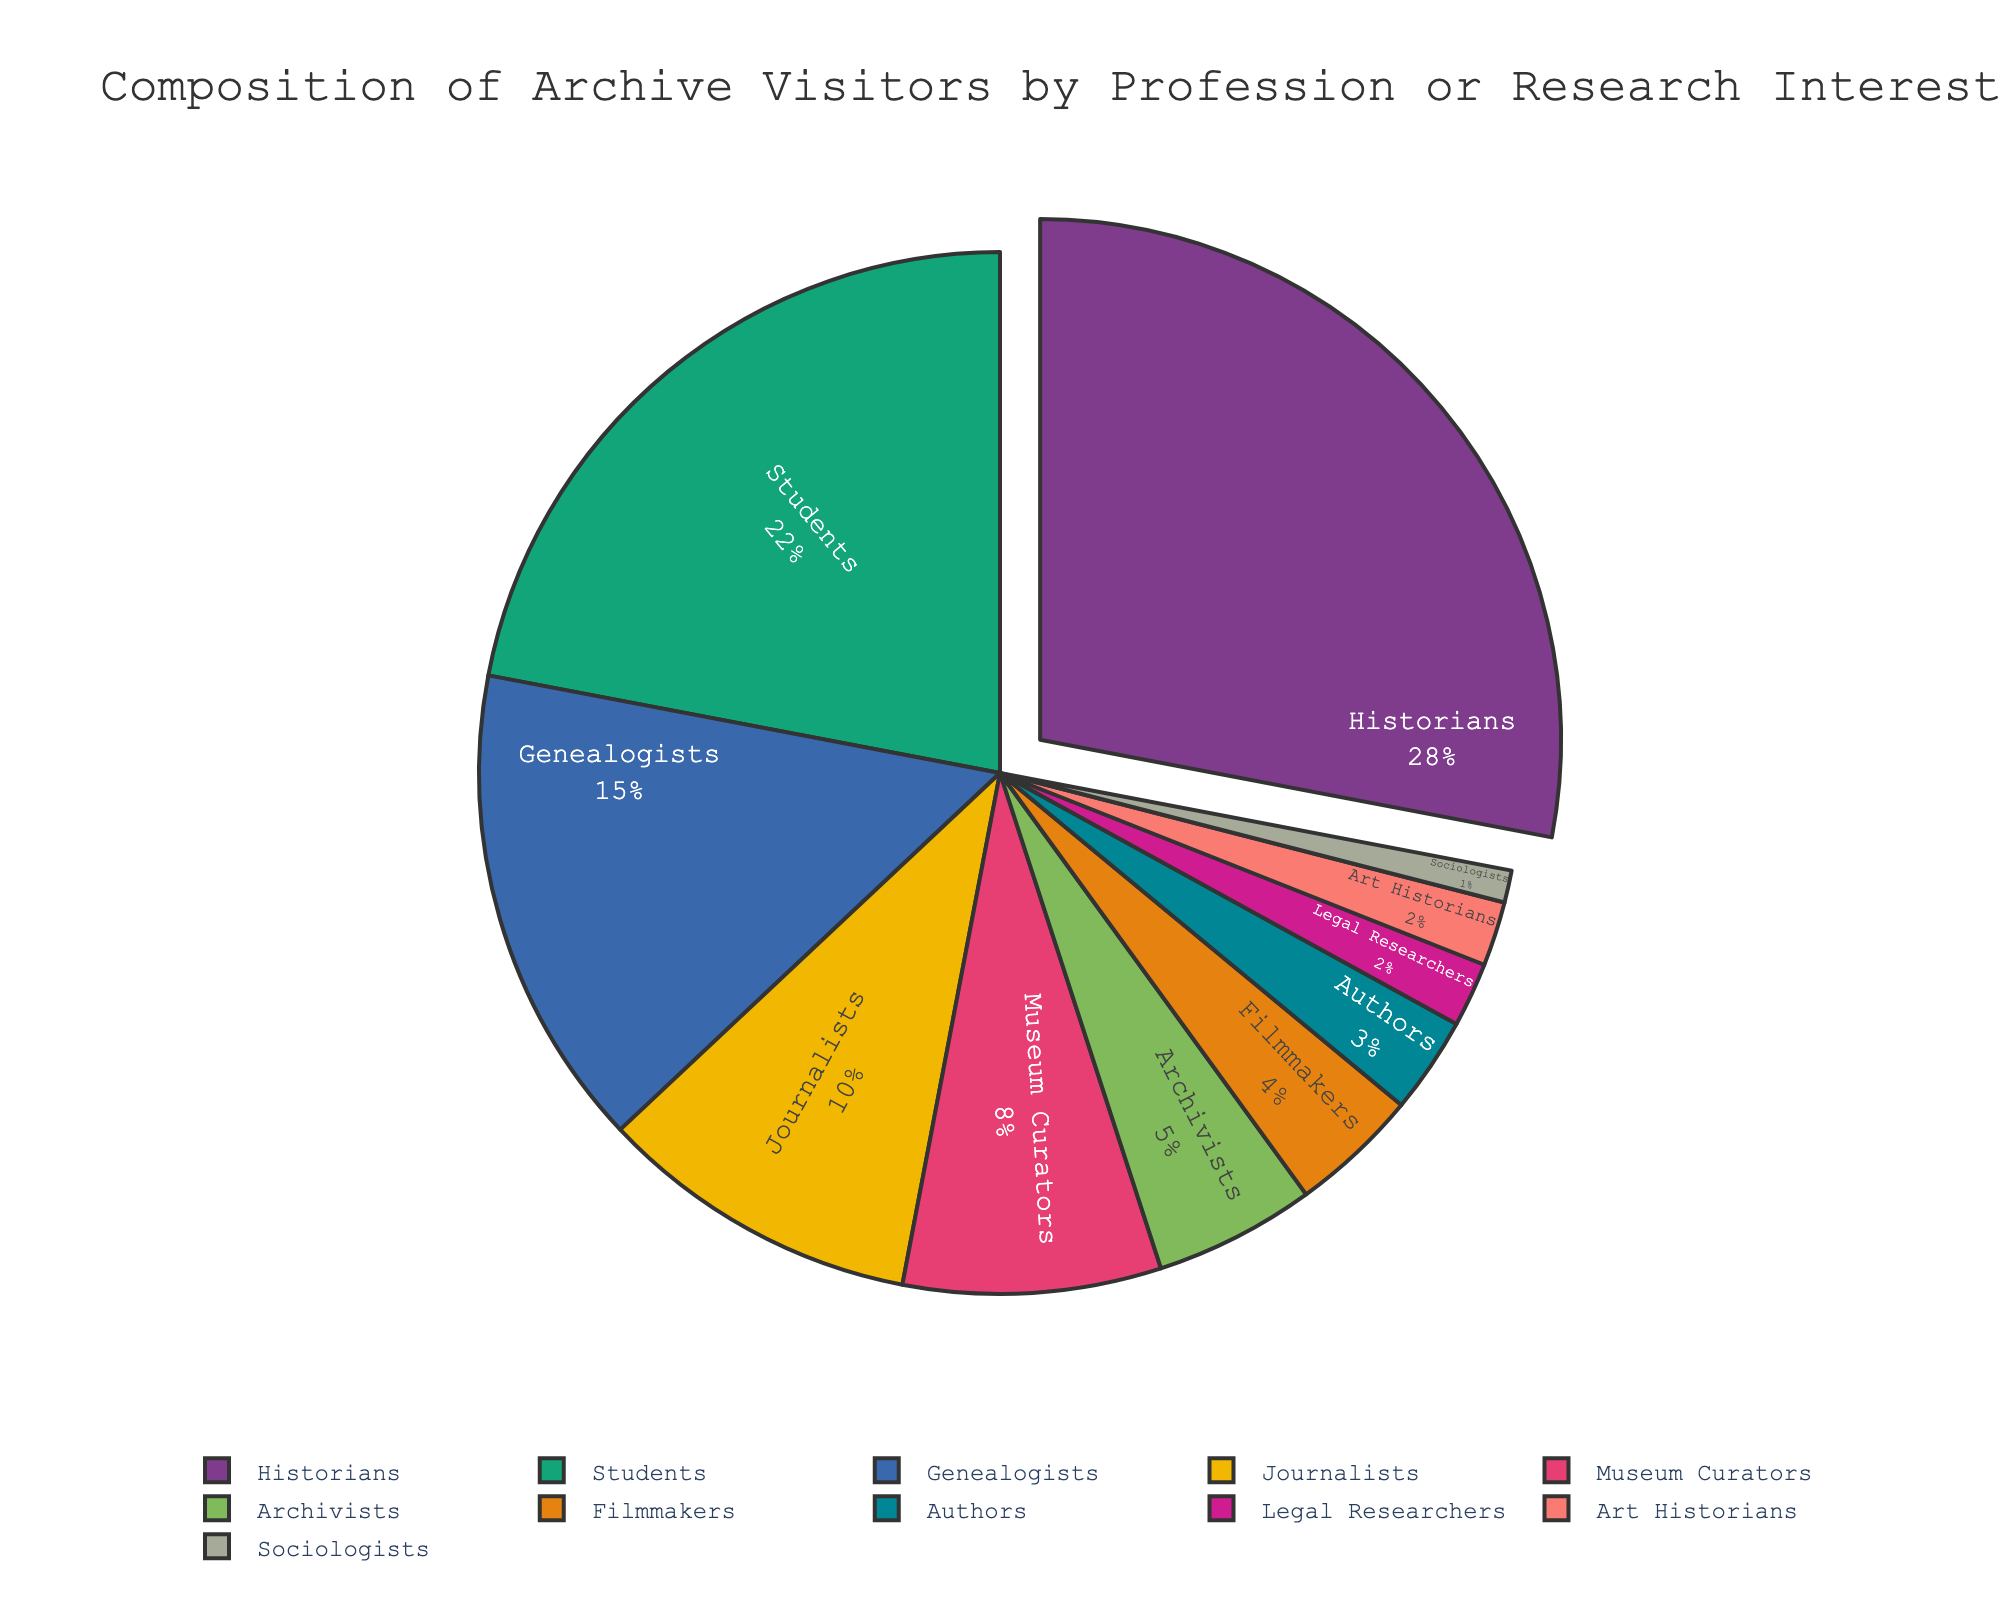What's the total percentage of archive visitors who are Historians, Students, and Genealogists? Sum the percentages for Historians (28), Students (22), and Genealogists (15). 28 + 22 + 15 = 65
Answer: 65 Which professional group comprises a larger percentage of archive visitors: Journalists or Museum Curators? Compare the percentages for Journalists (10) and Museum Curators (8). Since 10 > 8, Journalists have a larger percentage.
Answer: Journalists What percentage of the archive visitors are in the professions with single-digit percentages: Museum Curators, Archivists, Filmmakers, Authors, Legal Researchers, Art Historians, and Sociologists? Sum the percentages for Museum Curators (8), Archivists (5), Filmmakers (4), Authors (3), Legal Researchers (2), Art Historians (2), and Sociologists (1). 8 + 5 + 4 + 3 + 2 + 2 + 1 = 25
Answer: 25 Which profession has the smallest percentage of archive visitors, and what is that percentage? Locate the smallest percentage in the pie chart, which is Sociologists, with 1%.
Answer: Sociologists, 1% What is the difference in percentage between Historians and Filmmakers? Subtract the percentage of Filmmakers (4) from Historians (28). 28 - 4 = 24
Answer: 24 How many professional groups have a percentage of visitors less than 5%? Count the professional groups with percentages less than 5: Filmmakers (4), Authors (3), Legal Researchers (2), Art Historians (2), and Sociologists (1). There are 5 such groups.
Answer: 5 What's the combined percentage of Filmmakers and Authors? Sum the percentages for Filmmakers (4) and Authors (3). 4 + 3 = 7
Answer: 7 Which professional group has the highest percentage and how is it visually emphasized in the pie chart? Historians have the highest percentage (28%) and this segment is slightly pulled out from the center.
Answer: Historians, pulled out What percentage of archive visitors do Journalists and Legal Researchers together represent? Sum the percentages for Journalists (10) and Legal Researchers (2). 10 + 2 = 12
Answer: 12 